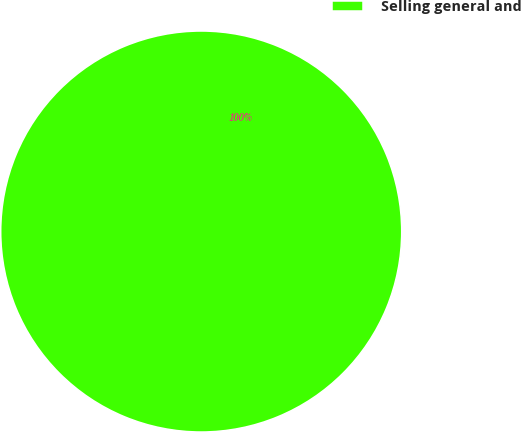Convert chart to OTSL. <chart><loc_0><loc_0><loc_500><loc_500><pie_chart><fcel>Selling general and<nl><fcel>100.0%<nl></chart> 